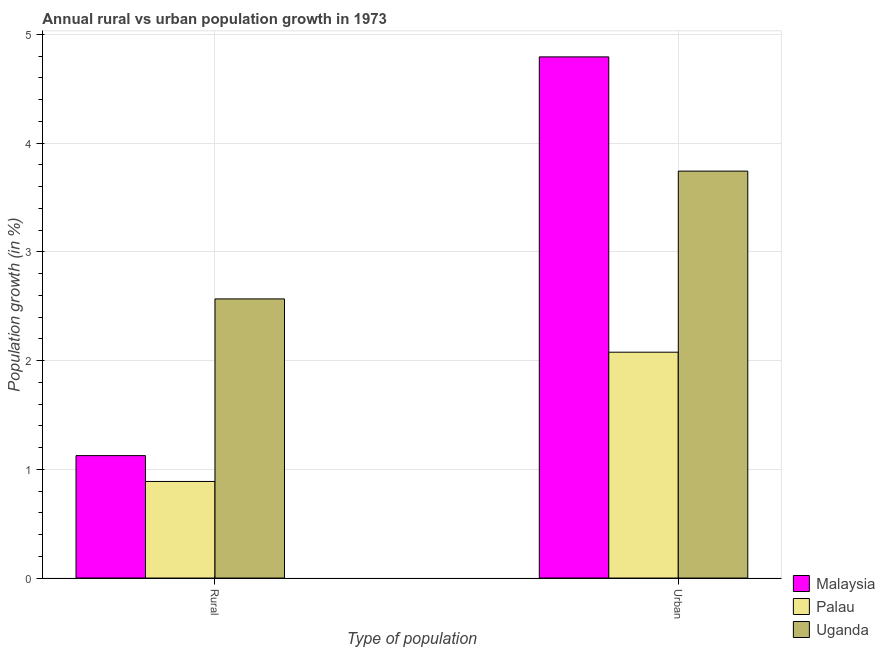Are the number of bars on each tick of the X-axis equal?
Offer a very short reply. Yes. How many bars are there on the 2nd tick from the right?
Provide a short and direct response. 3. What is the label of the 1st group of bars from the left?
Your answer should be compact. Rural. What is the urban population growth in Malaysia?
Give a very brief answer. 4.79. Across all countries, what is the maximum rural population growth?
Make the answer very short. 2.57. Across all countries, what is the minimum urban population growth?
Provide a short and direct response. 2.08. In which country was the rural population growth maximum?
Make the answer very short. Uganda. In which country was the rural population growth minimum?
Provide a short and direct response. Palau. What is the total rural population growth in the graph?
Your response must be concise. 4.58. What is the difference between the urban population growth in Malaysia and that in Uganda?
Make the answer very short. 1.05. What is the difference between the urban population growth in Palau and the rural population growth in Malaysia?
Provide a succinct answer. 0.95. What is the average rural population growth per country?
Your answer should be compact. 1.53. What is the difference between the rural population growth and urban population growth in Malaysia?
Make the answer very short. -3.67. What is the ratio of the urban population growth in Palau to that in Uganda?
Offer a very short reply. 0.55. What does the 2nd bar from the left in Urban  represents?
Keep it short and to the point. Palau. What does the 3rd bar from the right in Rural represents?
Keep it short and to the point. Malaysia. How many bars are there?
Your answer should be compact. 6. Are all the bars in the graph horizontal?
Ensure brevity in your answer.  No. What is the difference between two consecutive major ticks on the Y-axis?
Give a very brief answer. 1. Does the graph contain any zero values?
Provide a short and direct response. No. Where does the legend appear in the graph?
Ensure brevity in your answer.  Bottom right. How are the legend labels stacked?
Offer a terse response. Vertical. What is the title of the graph?
Provide a succinct answer. Annual rural vs urban population growth in 1973. Does "United States" appear as one of the legend labels in the graph?
Give a very brief answer. No. What is the label or title of the X-axis?
Your answer should be compact. Type of population. What is the label or title of the Y-axis?
Ensure brevity in your answer.  Population growth (in %). What is the Population growth (in %) of Malaysia in Rural?
Provide a short and direct response. 1.13. What is the Population growth (in %) in Palau in Rural?
Your answer should be very brief. 0.89. What is the Population growth (in %) of Uganda in Rural?
Provide a succinct answer. 2.57. What is the Population growth (in %) of Malaysia in Urban ?
Offer a very short reply. 4.79. What is the Population growth (in %) of Palau in Urban ?
Give a very brief answer. 2.08. What is the Population growth (in %) of Uganda in Urban ?
Your answer should be very brief. 3.74. Across all Type of population, what is the maximum Population growth (in %) of Malaysia?
Provide a short and direct response. 4.79. Across all Type of population, what is the maximum Population growth (in %) of Palau?
Give a very brief answer. 2.08. Across all Type of population, what is the maximum Population growth (in %) in Uganda?
Offer a terse response. 3.74. Across all Type of population, what is the minimum Population growth (in %) in Malaysia?
Offer a very short reply. 1.13. Across all Type of population, what is the minimum Population growth (in %) of Palau?
Give a very brief answer. 0.89. Across all Type of population, what is the minimum Population growth (in %) of Uganda?
Offer a terse response. 2.57. What is the total Population growth (in %) in Malaysia in the graph?
Give a very brief answer. 5.92. What is the total Population growth (in %) in Palau in the graph?
Give a very brief answer. 2.97. What is the total Population growth (in %) of Uganda in the graph?
Your answer should be very brief. 6.31. What is the difference between the Population growth (in %) in Malaysia in Rural and that in Urban ?
Provide a succinct answer. -3.67. What is the difference between the Population growth (in %) in Palau in Rural and that in Urban ?
Your answer should be very brief. -1.19. What is the difference between the Population growth (in %) in Uganda in Rural and that in Urban ?
Ensure brevity in your answer.  -1.18. What is the difference between the Population growth (in %) in Malaysia in Rural and the Population growth (in %) in Palau in Urban?
Your response must be concise. -0.95. What is the difference between the Population growth (in %) in Malaysia in Rural and the Population growth (in %) in Uganda in Urban?
Your response must be concise. -2.62. What is the difference between the Population growth (in %) of Palau in Rural and the Population growth (in %) of Uganda in Urban?
Your answer should be very brief. -2.85. What is the average Population growth (in %) in Malaysia per Type of population?
Keep it short and to the point. 2.96. What is the average Population growth (in %) in Palau per Type of population?
Your response must be concise. 1.48. What is the average Population growth (in %) in Uganda per Type of population?
Make the answer very short. 3.16. What is the difference between the Population growth (in %) of Malaysia and Population growth (in %) of Palau in Rural?
Keep it short and to the point. 0.24. What is the difference between the Population growth (in %) of Malaysia and Population growth (in %) of Uganda in Rural?
Offer a very short reply. -1.44. What is the difference between the Population growth (in %) in Palau and Population growth (in %) in Uganda in Rural?
Your response must be concise. -1.68. What is the difference between the Population growth (in %) of Malaysia and Population growth (in %) of Palau in Urban ?
Your answer should be very brief. 2.72. What is the difference between the Population growth (in %) of Malaysia and Population growth (in %) of Uganda in Urban ?
Offer a terse response. 1.05. What is the difference between the Population growth (in %) in Palau and Population growth (in %) in Uganda in Urban ?
Ensure brevity in your answer.  -1.67. What is the ratio of the Population growth (in %) in Malaysia in Rural to that in Urban ?
Your response must be concise. 0.23. What is the ratio of the Population growth (in %) of Palau in Rural to that in Urban ?
Your answer should be very brief. 0.43. What is the ratio of the Population growth (in %) of Uganda in Rural to that in Urban ?
Offer a very short reply. 0.69. What is the difference between the highest and the second highest Population growth (in %) of Malaysia?
Keep it short and to the point. 3.67. What is the difference between the highest and the second highest Population growth (in %) in Palau?
Your response must be concise. 1.19. What is the difference between the highest and the second highest Population growth (in %) of Uganda?
Provide a succinct answer. 1.18. What is the difference between the highest and the lowest Population growth (in %) in Malaysia?
Your response must be concise. 3.67. What is the difference between the highest and the lowest Population growth (in %) of Palau?
Your answer should be very brief. 1.19. What is the difference between the highest and the lowest Population growth (in %) in Uganda?
Keep it short and to the point. 1.18. 